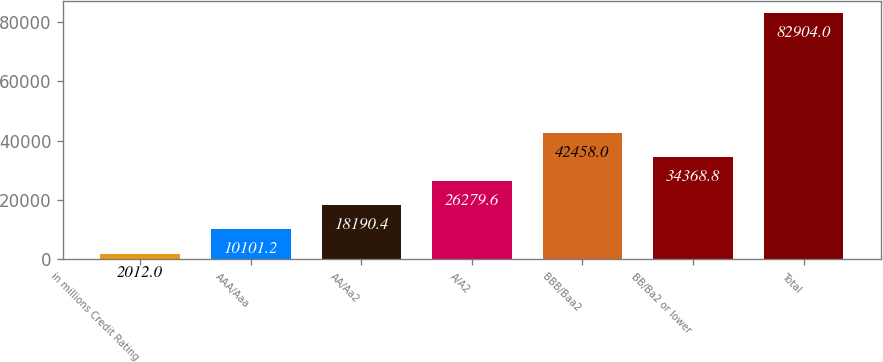Convert chart. <chart><loc_0><loc_0><loc_500><loc_500><bar_chart><fcel>in millions Credit Rating<fcel>AAA/Aaa<fcel>AA/Aa2<fcel>A/A2<fcel>BBB/Baa2<fcel>BB/Ba2 or lower<fcel>Total<nl><fcel>2012<fcel>10101.2<fcel>18190.4<fcel>26279.6<fcel>42458<fcel>34368.8<fcel>82904<nl></chart> 